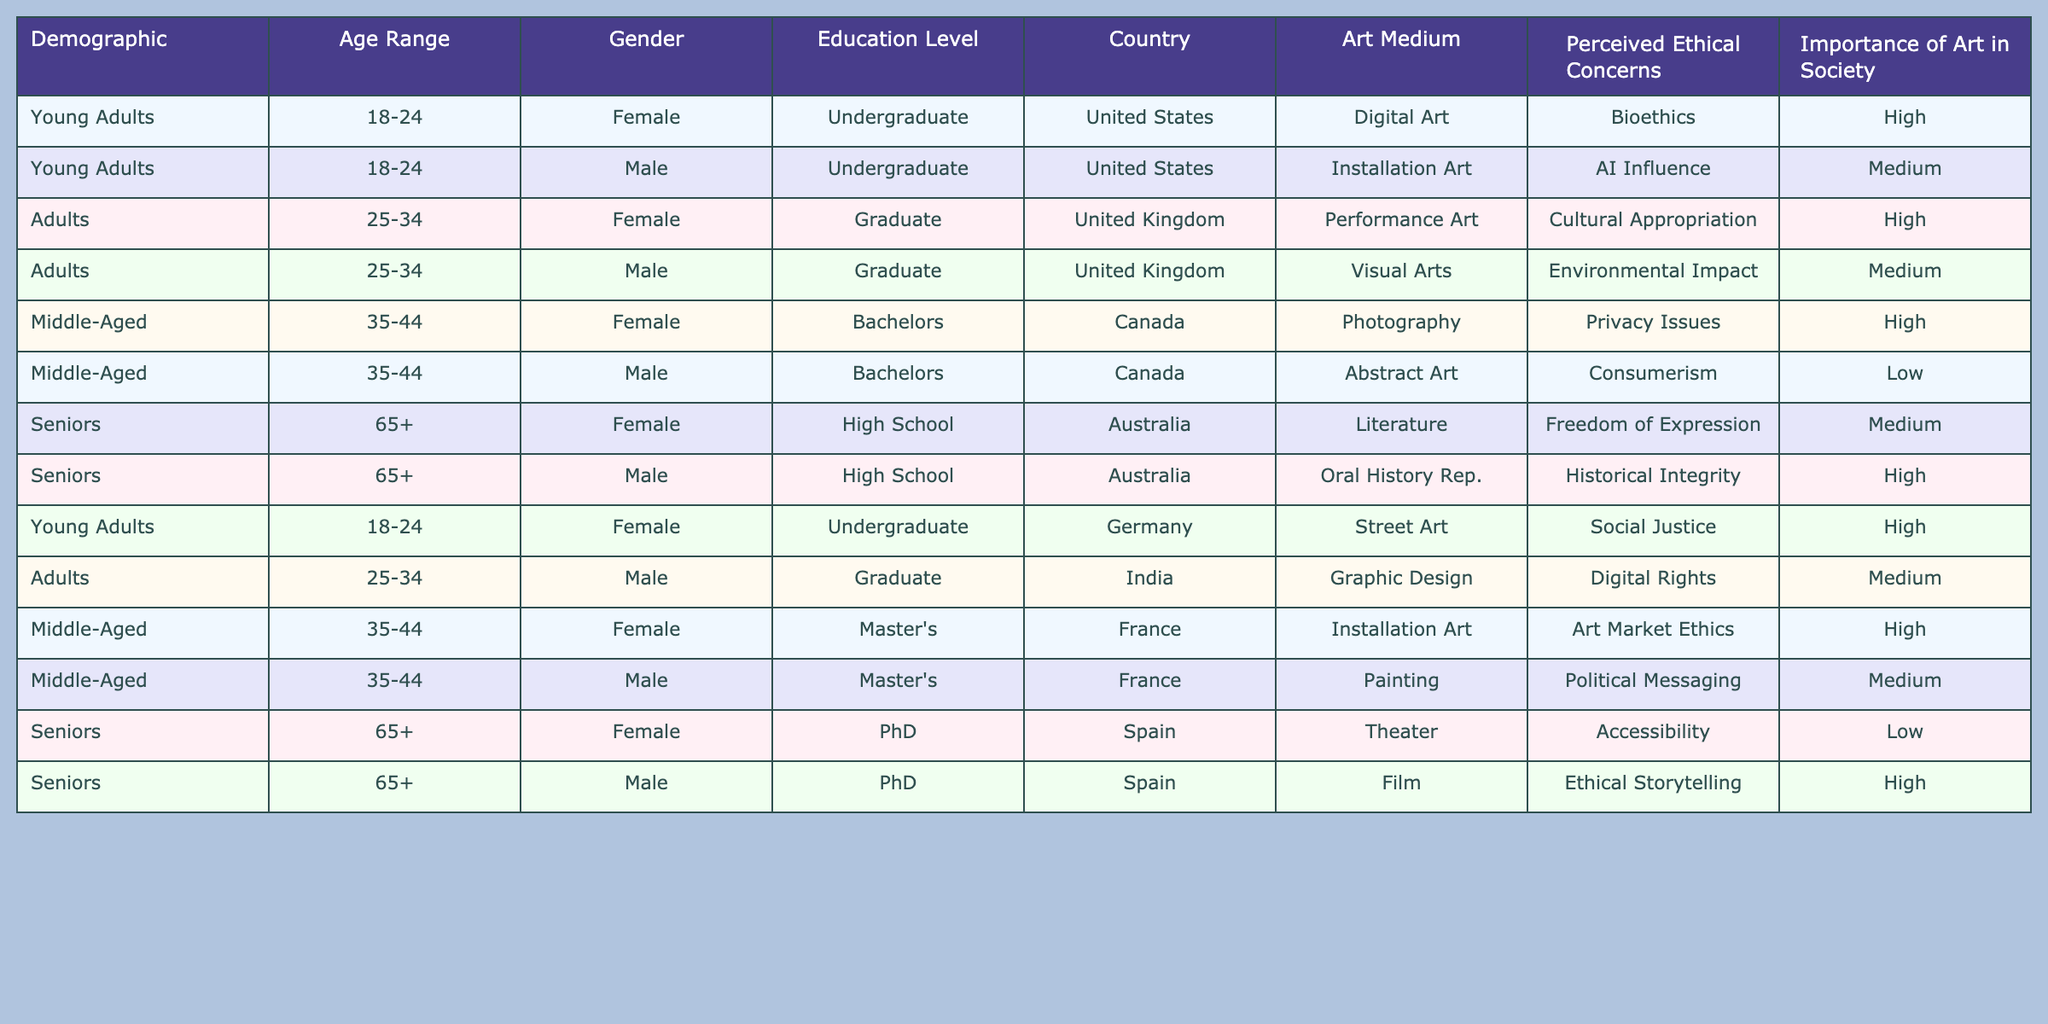What is the perceived ethical concern for Digital Art among Young Adults in the United States? According to the table, the perceived ethical concern for Digital Art among Young Adults in the United States is Bioethics.
Answer: Bioethics How many art mediums are listed for Adults aged 25-34 in the UK? There are two art mediums listed for Adults aged 25-34 in the UK: Performance Art and Visual Arts.
Answer: 2 Which demographic group has the highest reported perceived ethical concern for Performance Art? The demographic group that has the highest reported perceived ethical concern for Performance Art is Adults aged 25-34, Female, in the United Kingdom, with a concern level categorized as High.
Answer: Adults, 25-34, Female, UK What is the perceived ethical concern level for Abstract Art among Middle-Aged males in Canada? The perceived ethical concern level for Abstract Art among Middle-Aged males in Canada is Low, as indicated in the table.
Answer: Low Which art medium is associated with the highest importance of art in society reported by Young Adults in Germany? The art medium associated with the highest importance of art in society reported by Young Adults in Germany is Street Art, which has a perceived ethical concern of Social Justice and a rated importance of High.
Answer: Street Art Are there any Seniors who perceive Ethical Storytelling as a high ethical concern? Yes, the data shows that Seniors aged 65+ male in Spain perceive Ethical Storytelling as a high ethical concern.
Answer: Yes What is the average perceived ethical concern level for Middle-Aged Females across all countries? For Middle-Aged Females, the perceived ethical concerns reported are: Privacy Issues (High), Cultural Appropriation (High), Art Market Ethics (High), totaling three High concerns out of three entries, resulting in an average perceived ethical concern level of High.
Answer: High How do the perceived ethical concerns vary across different art mediums among Seniors? Among Seniors, Literature has a Medium concern, while Oral History Representation has High; hence, there is a variation where one is Medium and the other High, showing a difference in ethical concerns across the art mediums.
Answer: Varies (Medium and High) What is the correlation between education level and perceived ethical concerns for Digital Rights in graphic design among Adults? The table indicates that for Adults aged 25-34 in India with Graduate level education, the perceived ethical concern for Digital Rights in graphic design is Medium, indicating a correlation where higher education associates with a recognized ethical concern.
Answer: Medium Does any demographic group report AI Influence as a perceived ethical concern? Yes, the demographic group of Young Adults aged 18-24, Male, in the United States reports AI Influence as a Medium perceived ethical concern associated with Installation Art.
Answer: Yes 